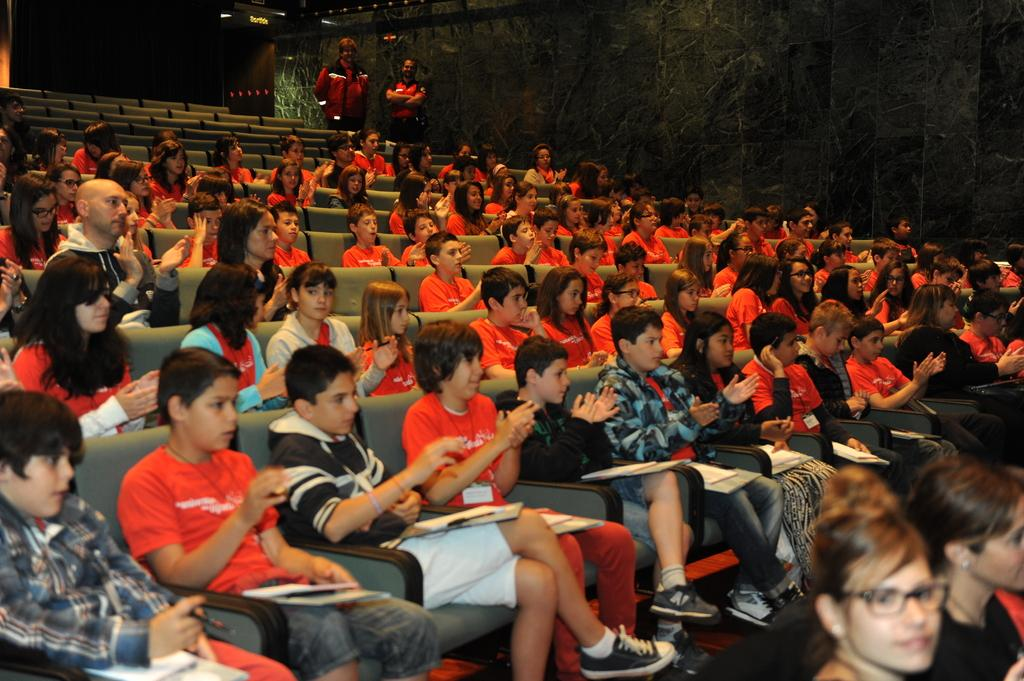How many children are in the image? There are many children in the image. What are the children doing in the image? The children are sitting on chairs and holding items. What can be seen in the background of the image? There is a wall in the background of the image. Are there any adults present in the image? Yes, there are two people standing in the image. What type of zebra can be seen grazing in the dirt in the image? There is no zebra or dirt present in the image; it features children sitting on chairs and holding items. 